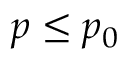Convert formula to latex. <formula><loc_0><loc_0><loc_500><loc_500>p \leq p _ { 0 }</formula> 